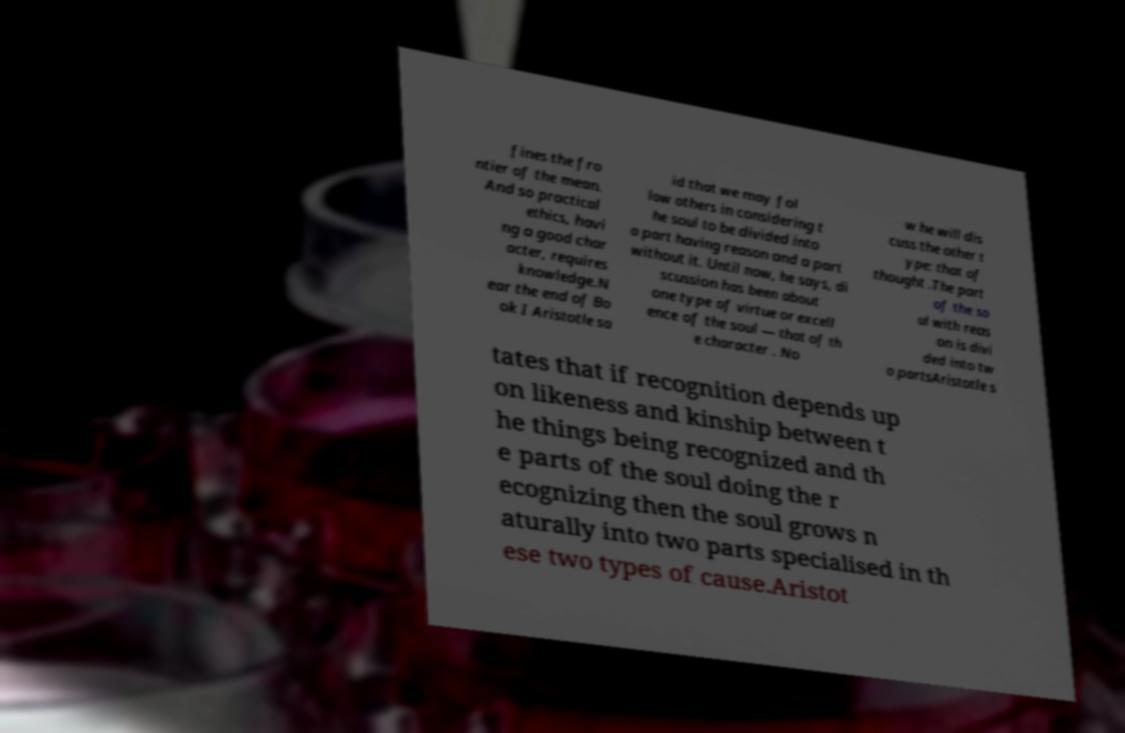There's text embedded in this image that I need extracted. Can you transcribe it verbatim? fines the fro ntier of the mean. And so practical ethics, havi ng a good char acter, requires knowledge.N ear the end of Bo ok I Aristotle sa id that we may fol low others in considering t he soul to be divided into a part having reason and a part without it. Until now, he says, di scussion has been about one type of virtue or excell ence of the soul — that of th e character . No w he will dis cuss the other t ype: that of thought .The part of the so ul with reas on is divi ded into tw o partsAristotle s tates that if recognition depends up on likeness and kinship between t he things being recognized and th e parts of the soul doing the r ecognizing then the soul grows n aturally into two parts specialised in th ese two types of cause.Aristot 